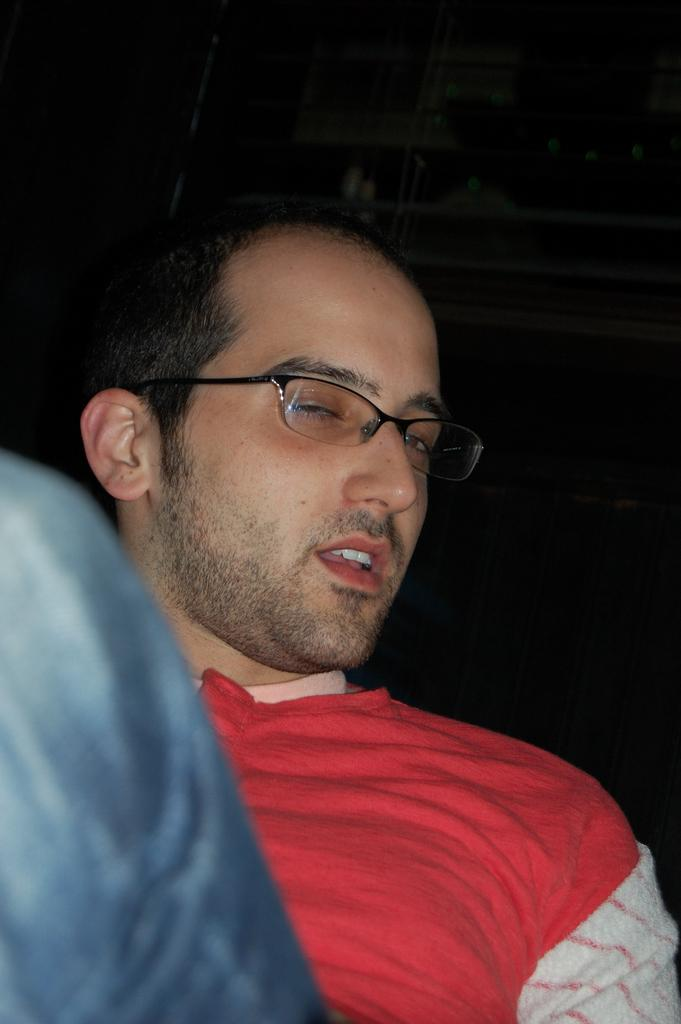Who is present in the image? There is a man in the image. What accessory is the man wearing? The man is wearing spectacles. What can be observed about the background of the image? The background of the image is dark. What type of drawer is visible in the image? There is no drawer present in the image. What board game is being played in the image? There is no board game present in the image. 